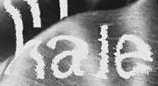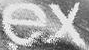What text is displayed in these images sequentially, separated by a semicolon? hale; ex 